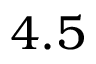Convert formula to latex. <formula><loc_0><loc_0><loc_500><loc_500>4 . 5</formula> 